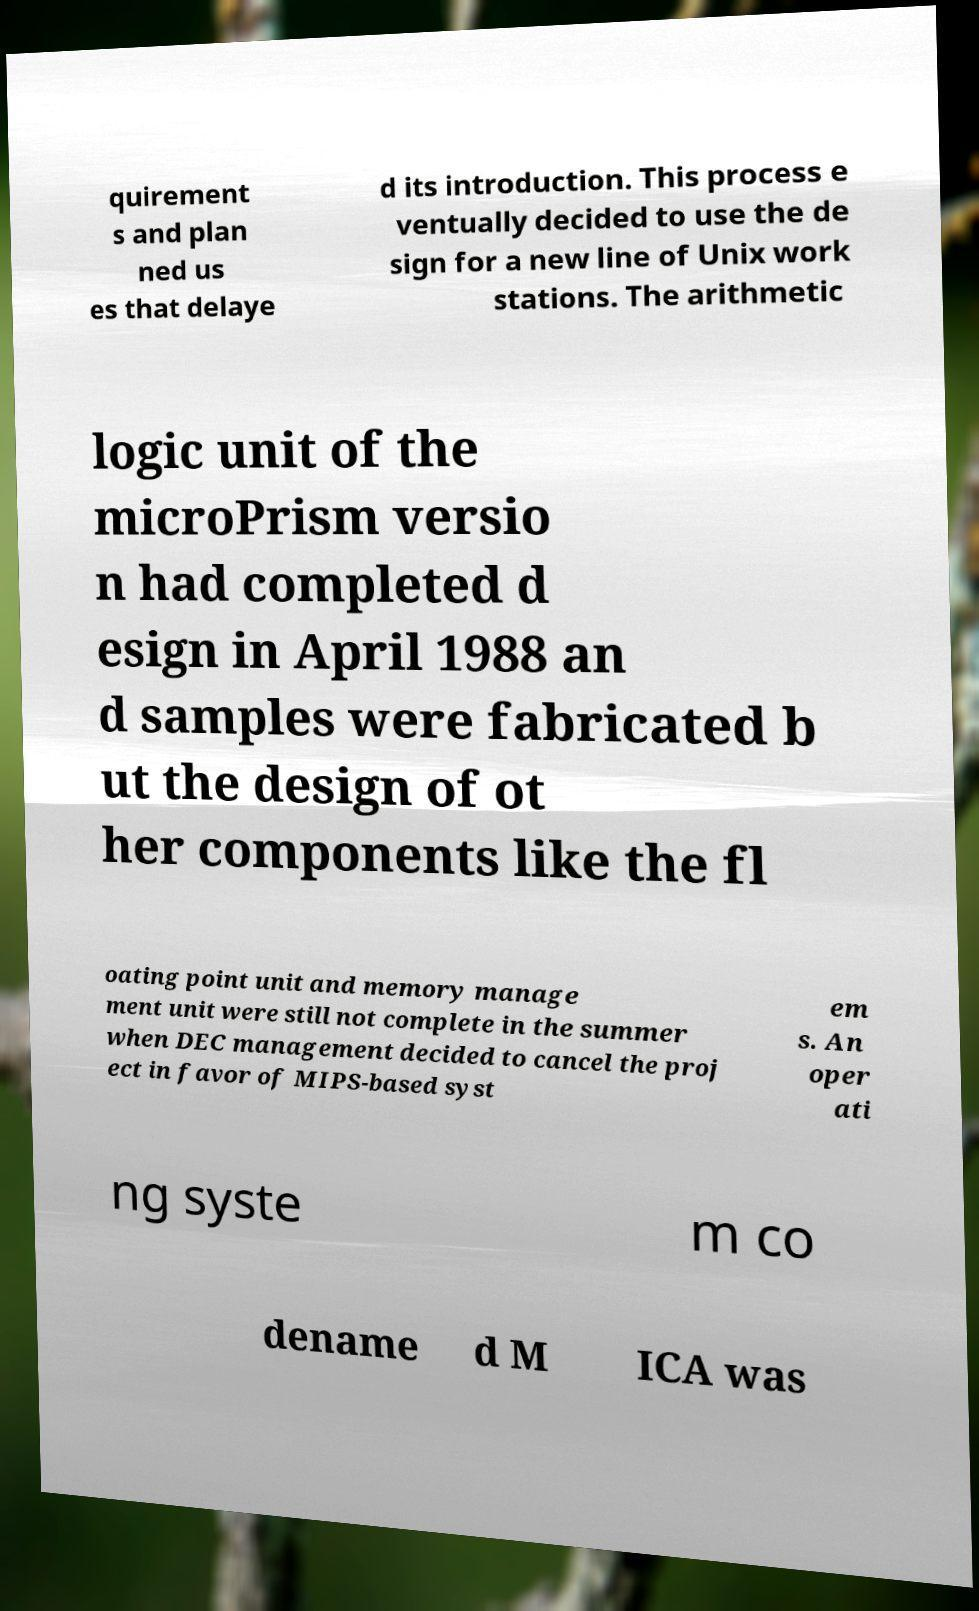For documentation purposes, I need the text within this image transcribed. Could you provide that? quirement s and plan ned us es that delaye d its introduction. This process e ventually decided to use the de sign for a new line of Unix work stations. The arithmetic logic unit of the microPrism versio n had completed d esign in April 1988 an d samples were fabricated b ut the design of ot her components like the fl oating point unit and memory manage ment unit were still not complete in the summer when DEC management decided to cancel the proj ect in favor of MIPS-based syst em s. An oper ati ng syste m co dename d M ICA was 